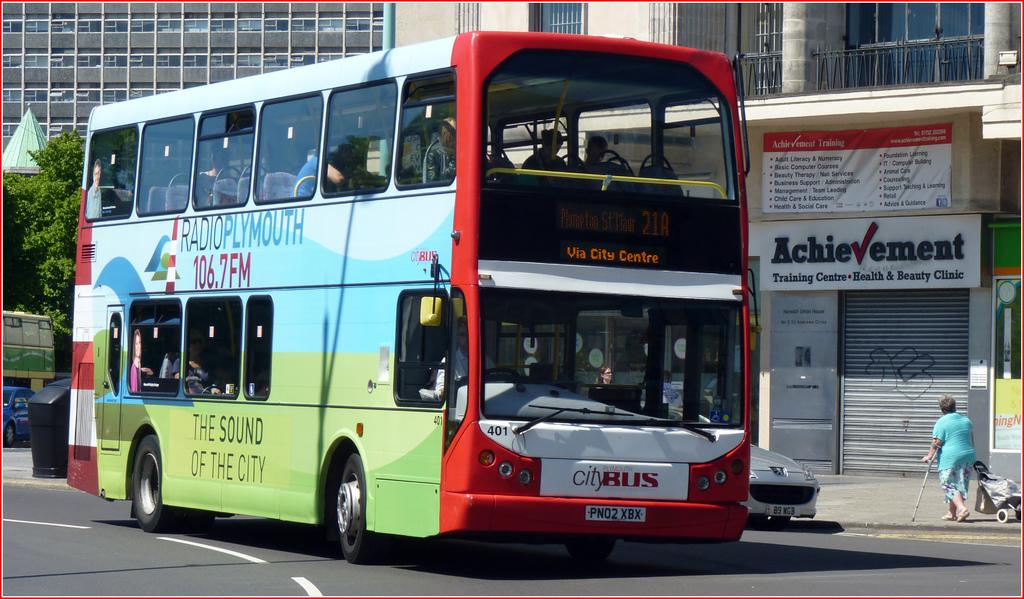<image>
Provide a brief description of the given image. A double decker City Bus trundles down the street along the Via City Center route. 